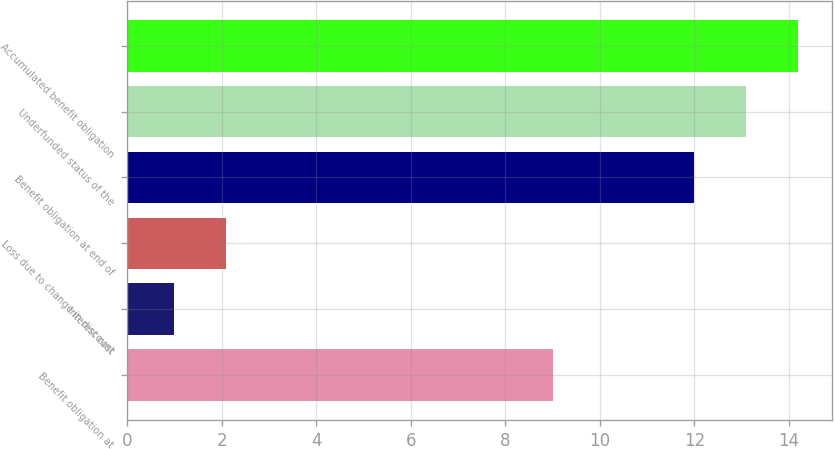Convert chart. <chart><loc_0><loc_0><loc_500><loc_500><bar_chart><fcel>Benefit obligation at<fcel>Interest cost<fcel>Loss due to change in discount<fcel>Benefit obligation at end of<fcel>Underfunded status of the<fcel>Accumulated benefit obligation<nl><fcel>9<fcel>1<fcel>2.1<fcel>12<fcel>13.1<fcel>14.2<nl></chart> 